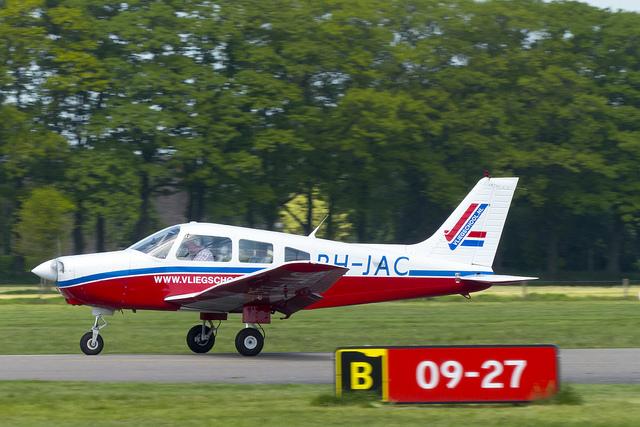How many wheels is on this plane?
Answer briefly. 3. What color is the bottom of the plane?
Concise answer only. Red. What colors are the plane?
Give a very brief answer. Red white and blue. Why is the helicopter in the middle of the roadway?
Give a very brief answer. Taking off. 